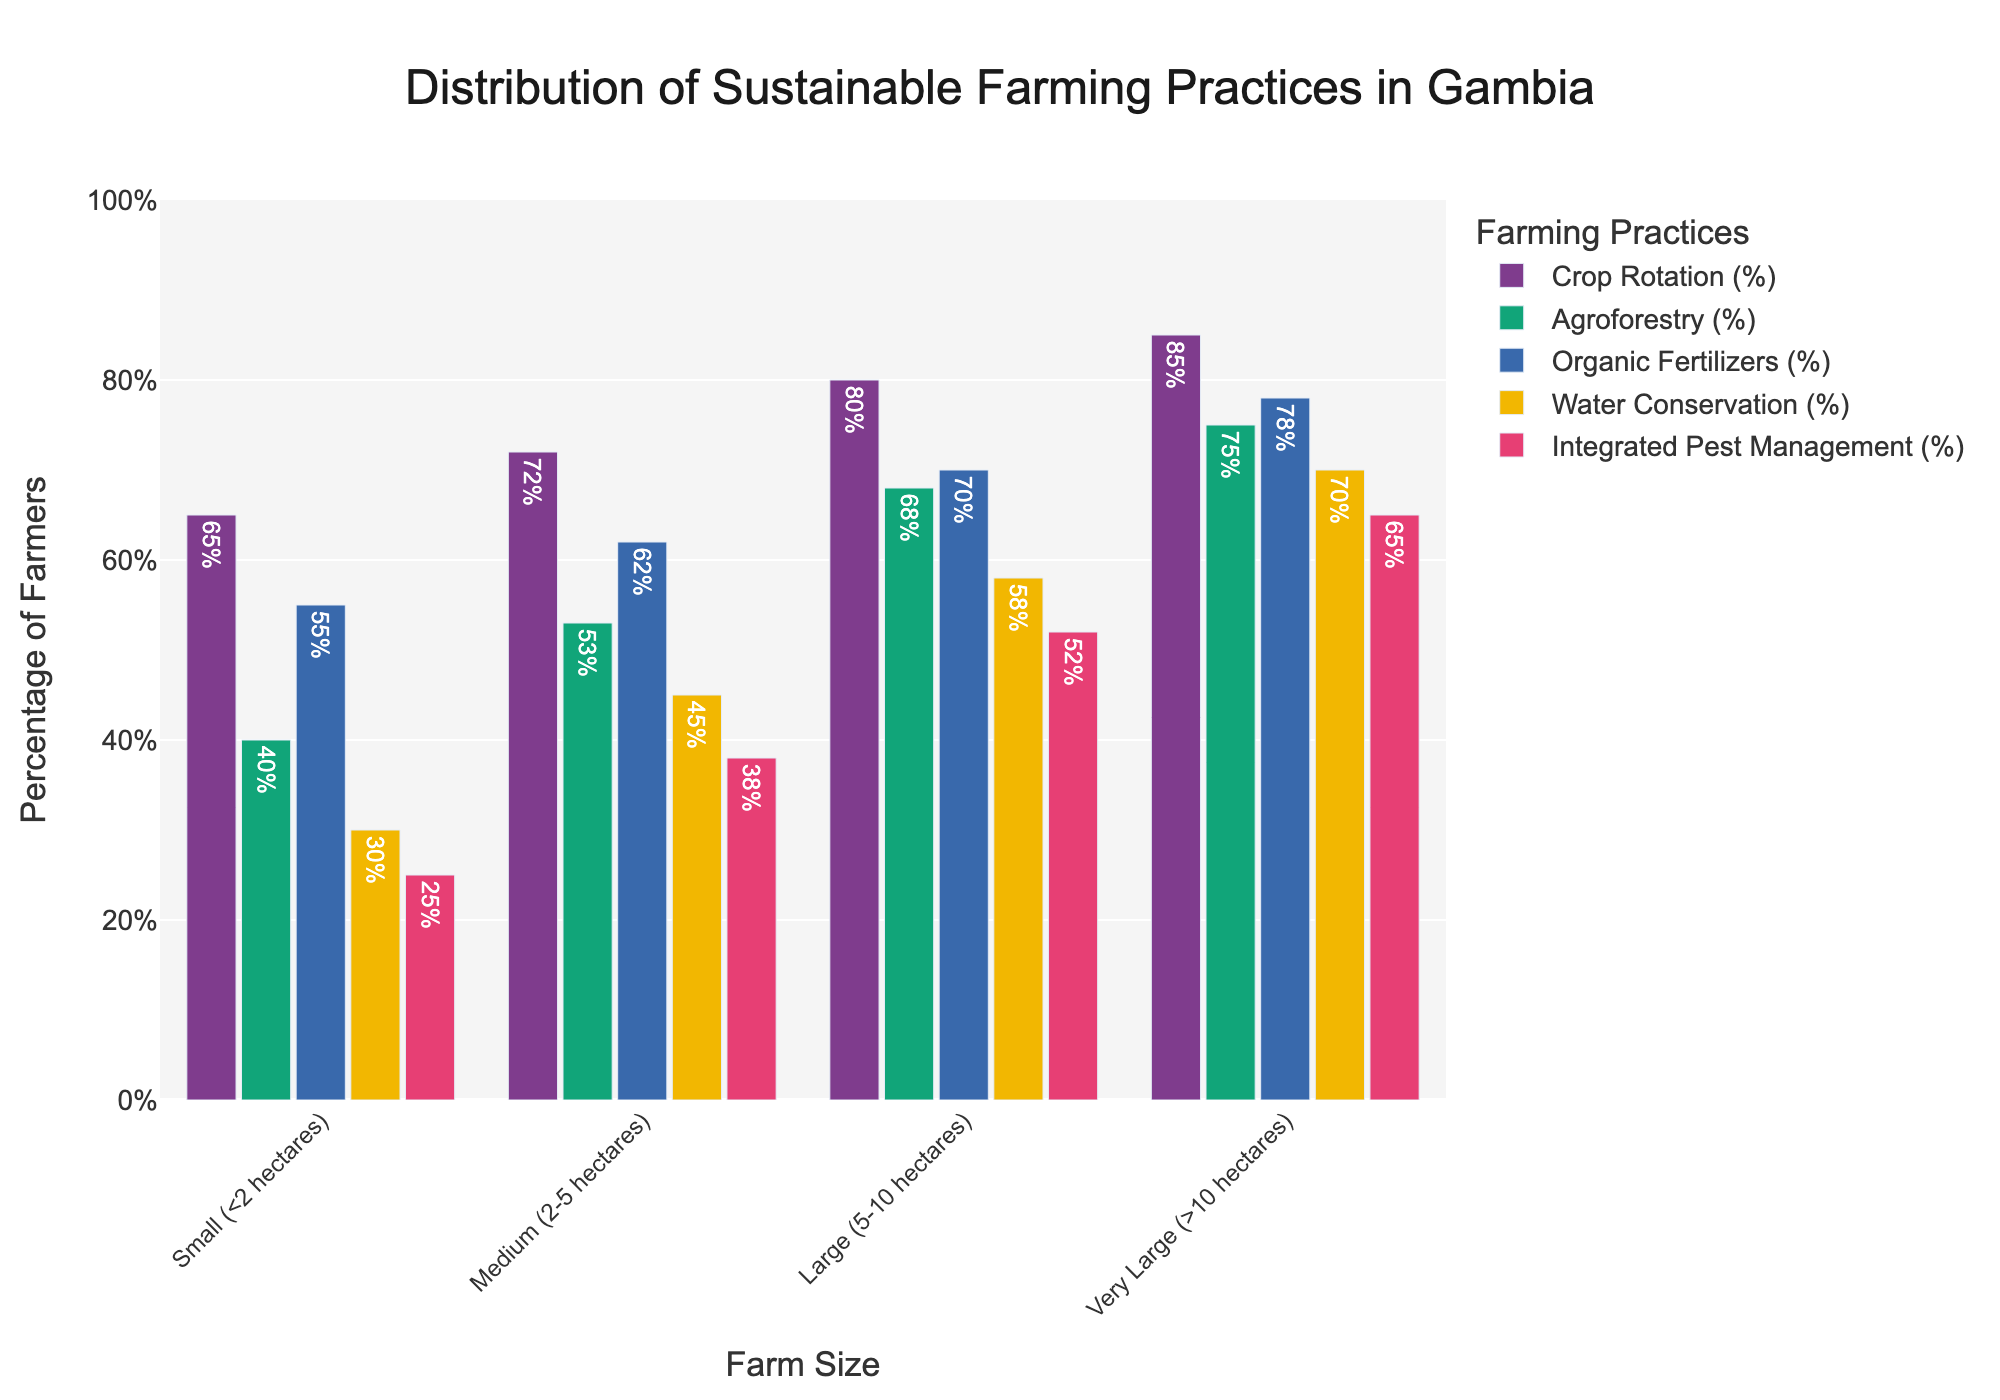Which farm size has the highest percentage of farmers practicing water conservation? By looking at the bar representing water conservation across different farm sizes, we can see which one is the tallest. The bar for "Very Large (>10 hectares)" farm size is the tallest.
Answer: Very Large (>10 hectares) What is the percentage difference between Small and Large farm sizes in practicing organic fertilizers? First, identify the organic fertilizers percentages for both Small and Large farm sizes, which are 55% and 70% respectively. Then, calculate the difference: 70% - 55% = 15%.
Answer: 15% Which sustainable farming practice is least prevalent among Small farm sizes? By comparing the heights of the bars for Small farm sizes across all practices, the shortest bar represents Integrated Pest Management at 25%.
Answer: Integrated Pest Management How does the usage of crop rotation among Medium farm sizes compare to that of Large farm sizes? The percentages for crop rotation for Medium and Large farm sizes are 72% and 80% respectively. Thus, crop rotation is more prevalent among Large farm sizes.
Answer: Larger Which farming practices have more than 60% adoption rate in Large farm sizes? Go through each bar for Large farm size to check if the value exceeds 60%. The practices with more than 60% are Crop Rotation (80%), Agroforestry (68%), Organic Fertilizers (70%), Water Conservation (58%), and Integrated Pest Management (52%).
Answer: Crop Rotation, Agroforestry, Organic Fertilizers What is the average percentage for Agroforestry practice across all farm sizes? Add up the percentages for Agroforestry across all farm sizes (40%+53%+68%+75%), which totals 236%, then divide by the number of farm sizes (4). The average is 236% / 4 = 59%.
Answer: 59% Compare the prevalence of integrated pest management practices between Medium and Very Large farm sizes. The percentages for Integrated Pest Management are 38% for Medium and 65% for Very Large farm sizes. Very Large has a higher percentage.
Answer: Very Large What is the total percentage of farmers using water conservation practices in Medium farm sizes and compare it to that in Very Large farm sizes? Add the percentages of water conservation in Medium (45%) and Very Large (70%) farm sizes. Compare the sums: 70% > 45%.
Answer: Less in Medium, 115% How does the percentage for using organic fertilizers in Very Large farm sizes compare to the average percentage of using organic fertilizers across all farm sizes? Find the percentage of using organic fertilizers in Very Large farm sizes (78%) and the average across all (55%, 62%, 70%, and 78%): (55% + 62% + 70% + 78%) / 4 = 66.25%. Compare 78% > 66.25%.
Answer: Higher What is the median percentage of farmers practicing agroforestry across all farm sizes? List the percentages for Agroforestry (40%, 53%, 68%, 75%). The median is the average of the two middle values: (53% + 68%) / 2 = 60.5%.
Answer: 60.5% 